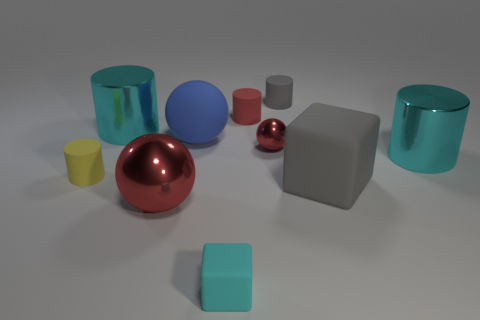Are there any two objects that look like they could function together? While these objects seem to be randomly placed and likely aren't meant to function together, one could imagine the cylinders and spheres being part of a playful sorting game for children, where objects of the same shape are grouped together. 